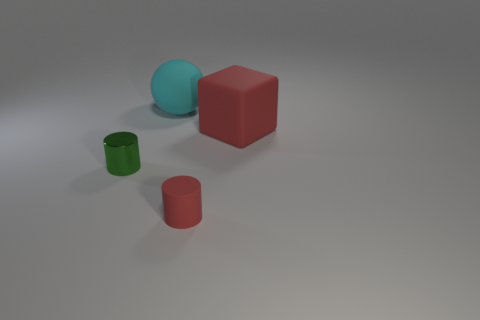Is there any other thing that is the same material as the tiny green cylinder?
Offer a terse response. No. Do the large object left of the large cube and the red object in front of the big red cube have the same material?
Keep it short and to the point. Yes. The thing that is the same color as the rubber block is what shape?
Provide a short and direct response. Cylinder. How many objects are small cylinders behind the red cylinder or red objects behind the red matte cylinder?
Give a very brief answer. 2. Is the color of the cylinder on the right side of the tiny green metal cylinder the same as the large thing left of the large matte cube?
Keep it short and to the point. No. What shape is the thing that is both behind the green metallic thing and to the left of the block?
Your answer should be very brief. Sphere. What is the color of the other object that is the same size as the green object?
Make the answer very short. Red. Are there any other big rubber spheres that have the same color as the sphere?
Keep it short and to the point. No. Do the cylinder that is on the left side of the large cyan thing and the red object behind the small red matte thing have the same size?
Offer a terse response. No. There is a thing that is to the left of the big red block and right of the large rubber ball; what is its material?
Your answer should be very brief. Rubber. 